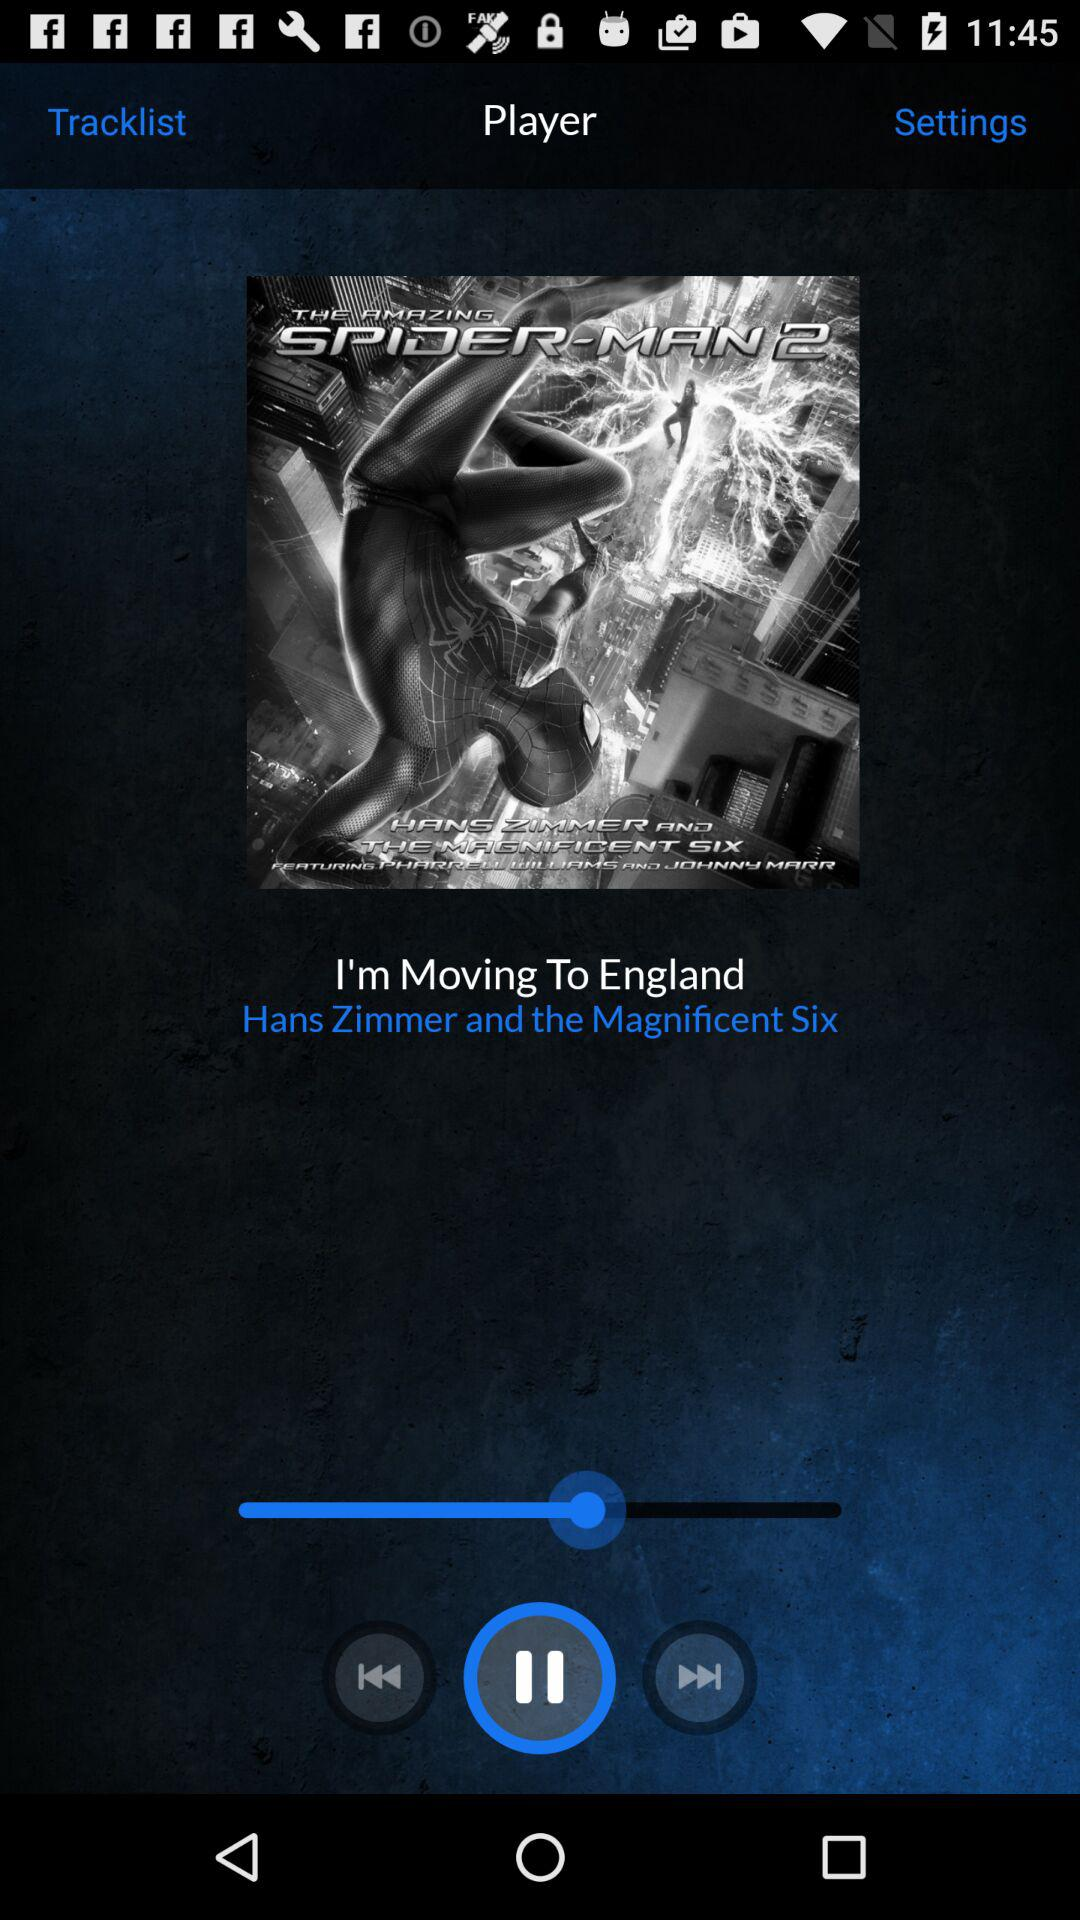What's the current playing song? The current playing song is "I'm Moving To England". 